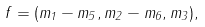Convert formula to latex. <formula><loc_0><loc_0><loc_500><loc_500>f = ( m _ { 1 } - m _ { 5 } , m _ { 2 } - m _ { 6 } , m _ { 3 } ) ,</formula> 